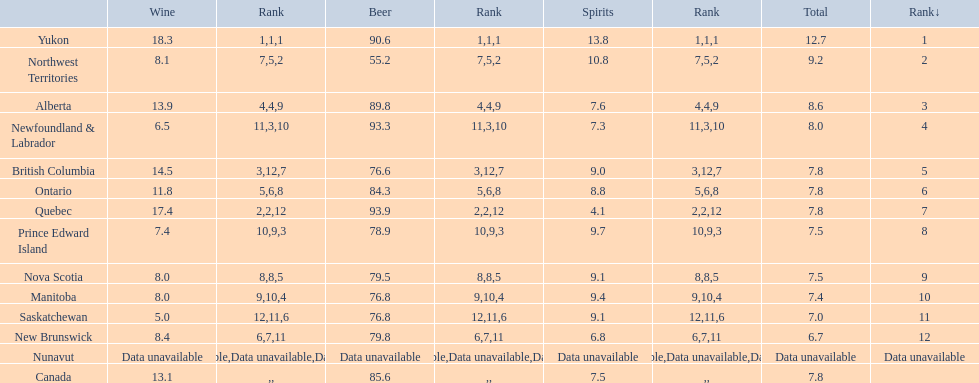What is the annual consumption of spirits in litres per person in yukon? 12.7. 